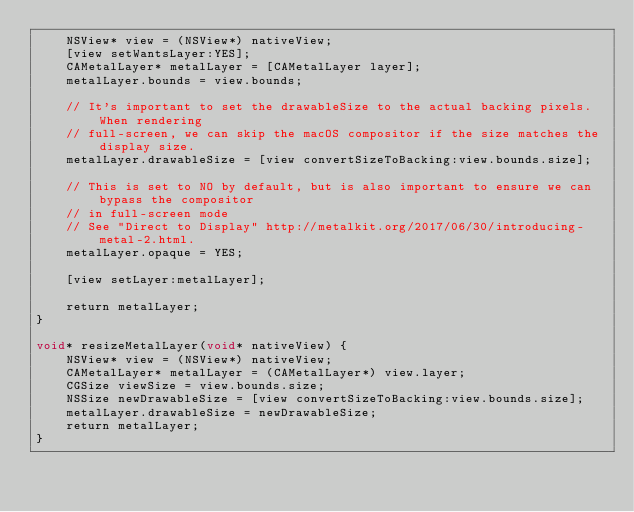Convert code to text. <code><loc_0><loc_0><loc_500><loc_500><_ObjectiveC_>    NSView* view = (NSView*) nativeView;
    [view setWantsLayer:YES];
    CAMetalLayer* metalLayer = [CAMetalLayer layer];
    metalLayer.bounds = view.bounds;

    // It's important to set the drawableSize to the actual backing pixels. When rendering
    // full-screen, we can skip the macOS compositor if the size matches the display size.
    metalLayer.drawableSize = [view convertSizeToBacking:view.bounds.size];

    // This is set to NO by default, but is also important to ensure we can bypass the compositor
    // in full-screen mode
    // See "Direct to Display" http://metalkit.org/2017/06/30/introducing-metal-2.html.
    metalLayer.opaque = YES;

    [view setLayer:metalLayer];

    return metalLayer;
}

void* resizeMetalLayer(void* nativeView) {
    NSView* view = (NSView*) nativeView;
    CAMetalLayer* metalLayer = (CAMetalLayer*) view.layer;
    CGSize viewSize = view.bounds.size;
    NSSize newDrawableSize = [view convertSizeToBacking:view.bounds.size];
    metalLayer.drawableSize = newDrawableSize;
    return metalLayer;
}
</code> 